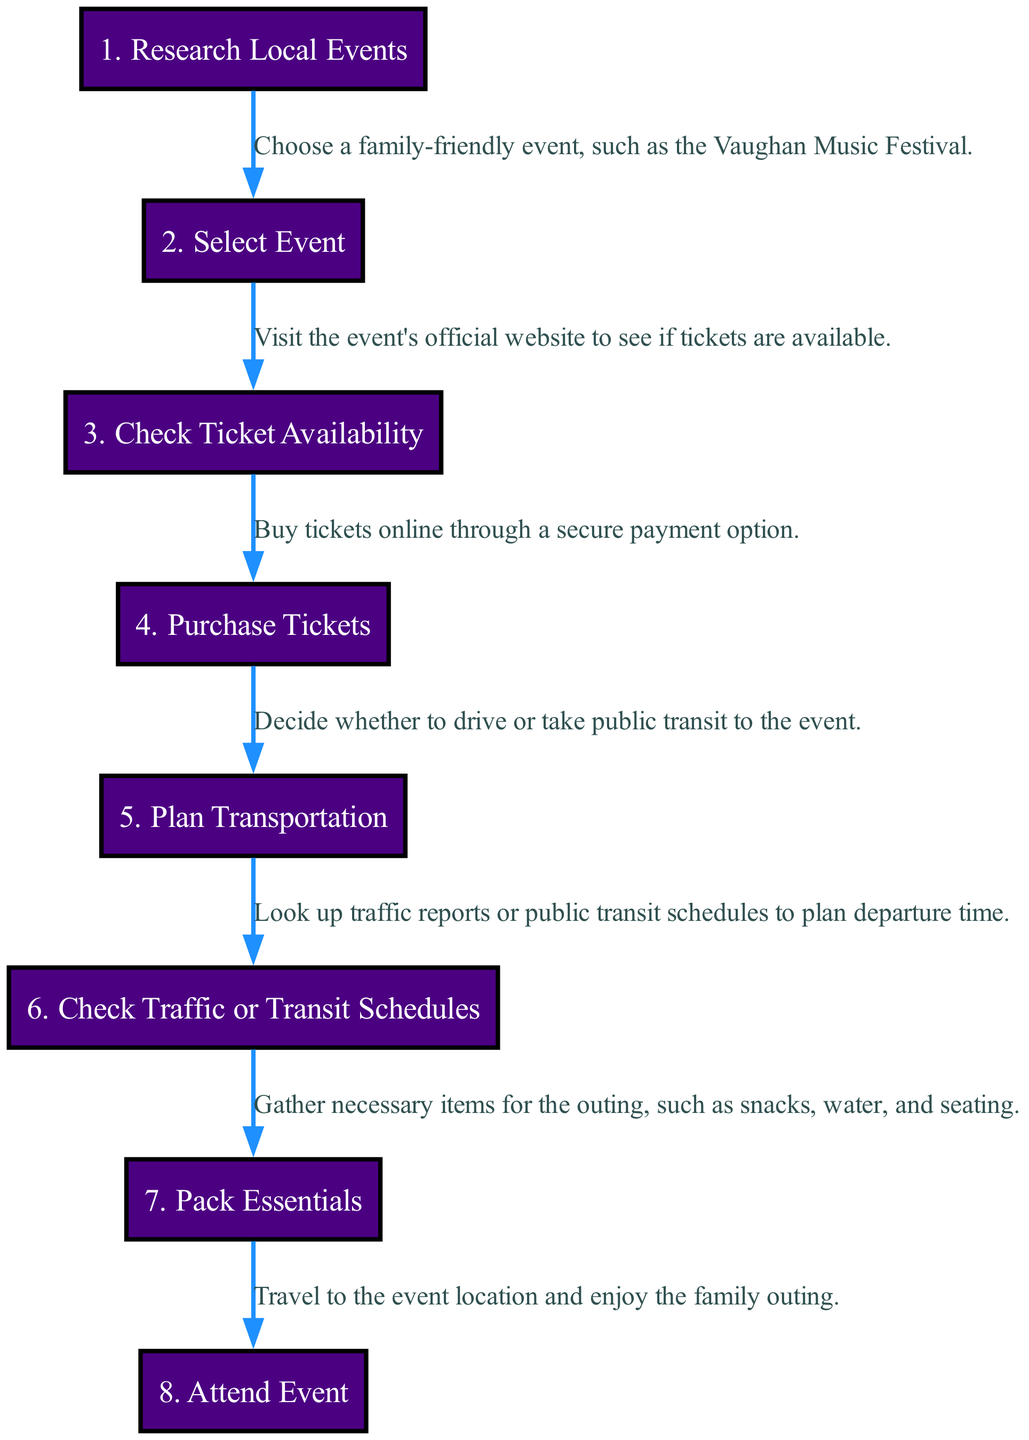What is the first step in the sequence? The first element in the diagram is "Research Local Events," which indicates the starting point of the planning process.
Answer: Research Local Events How many steps are there in total? By counting the elements listed in the diagram, there are eight distinct steps from researching local events to attending the event.
Answer: 8 What action is taken after purchasing tickets? After the "Purchase Tickets" step, the next action is "Plan Transportation," indicating the transition to organizing how to get to the event.
Answer: Plan Transportation Which step involves checking schedules for transit? The step "Check Traffic or Transit Schedules" directly pertains to looking up traffic reports or public transit schedules to prepare for the outing.
Answer: Check Traffic or Transit Schedules What is the main focus of the last step in the sequence? The last step, "Attend Event," focuses on the action of traveling to the event location and enjoying the outing which is the culmination of all previous steps.
Answer: Attend Event What is the relationship between "Select Event" and "Research Local Events"? "Select Event" follows "Research Local Events," meaning that the process of selecting an event occurs after researching local event options.
Answer: Select Event follows Research Local Events Which two steps are directly linked to logistics planning? "Plan Transportation" and "Check Traffic or Transit Schedules" are the two steps focused on logistics, as they deal with planning how to get to the event and the timing involved.
Answer: Plan Transportation and Check Traffic or Transit Schedules At what point do you gather necessary items for the outing? The "Pack Essentials" step occurs after planning transportation and checking schedules, showing that preparation for the outing comes after making logistical arrangements.
Answer: Pack Essentials What step immediately precedes "Attend Event"? The step just before "Attend Event" is "Pack Essentials," indicating that gathering items is completed right before traveling to the event.
Answer: Pack Essentials 